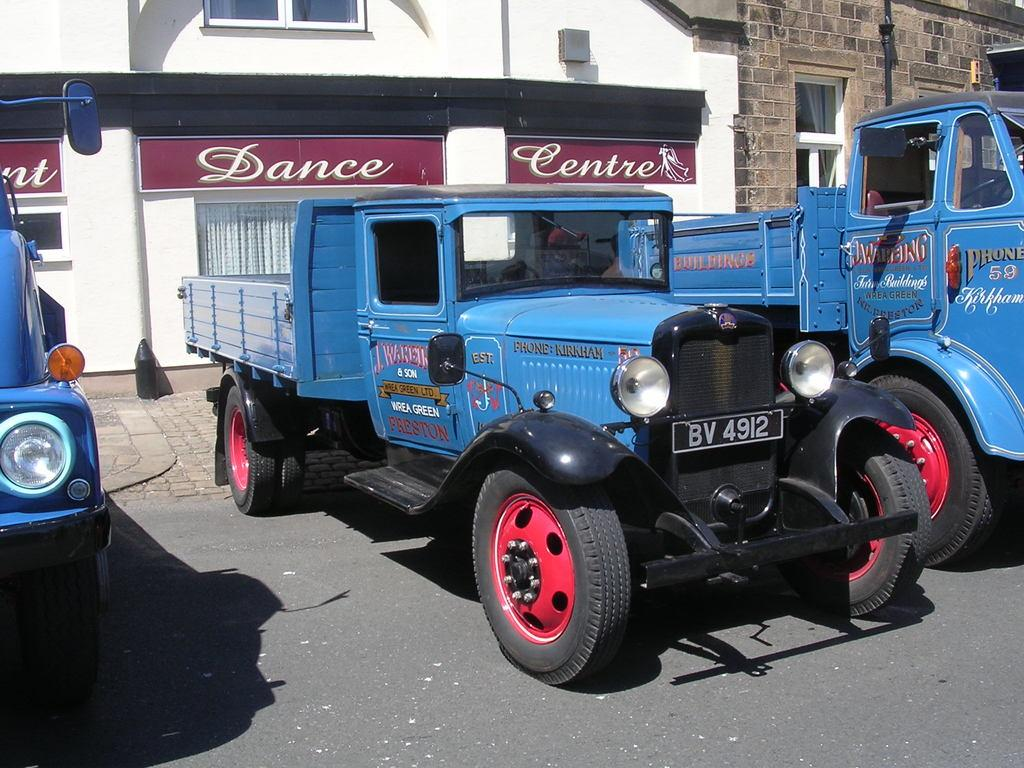What is happening on the road in the image? There are vehicles on the road in the image. What can be seen in the distance behind the vehicles? There are buildings visible in the background of the image. Where is the can of paint located in the image? There is no can of paint present in the image. What type of ticket can be seen in the image? There is no ticket present in the image. 